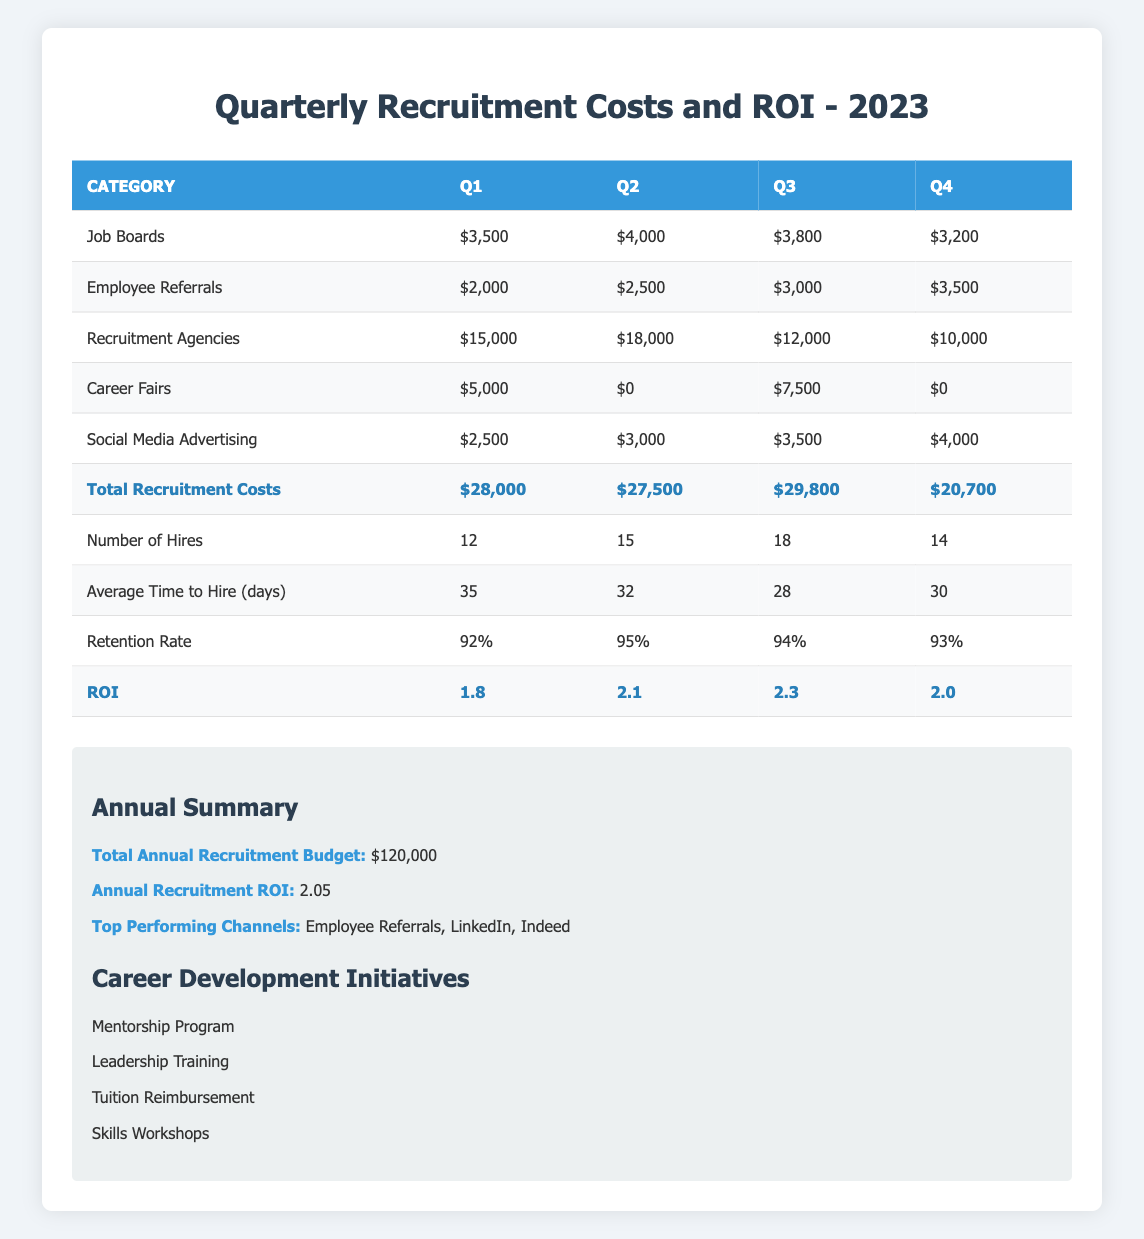What were the total recruitment costs for Q3? The total recruitment costs for Q3 can be found by looking at the row labeled "Total Recruitment Costs" in the Q3 column. The value there is $29,800.
Answer: $29,800 What was the average time to hire in Q2? In the table under the "Average Time to Hire (days)" row for Q2, the value is listed as 32 days.
Answer: 32 days Which quarter had the highest retention rate? To find the highest retention rate, compare the values in the "Retention Rate" row across all quarters. Q2 has the highest value at 95%.
Answer: Q2 What is the total cost for Employee Referrals for the entire year? Sum the costs for Employee Referrals across all four quarters: $2,000 (Q1) + $2,500 (Q2) + $3,000 (Q3) + $3,500 (Q4) = $11,000.
Answer: $11,000 Was the ROI higher for Q3 than for Q1? Q3's ROI is 2.3, and Q1's ROI is 1.8. Since 2.3 is greater than 1.8, the statement is true.
Answer: Yes What is the difference in the number of hires between Q1 and Q4? The number of hires in Q1 is 12 and in Q4 is 14. The difference is 14 - 12 = 2.
Answer: 2 Which quarter had the lowest total recruitment costs, and what was that amount? By comparing the totals in the "Total Recruitment Costs" row, Q4 has the lowest total of $20,700.
Answer: Q4, $20,700 What was the average retention rate for the year? To find the average retention rate, sum the retention rates for all quarters (0.92 + 0.95 + 0.94 + 0.93) and divide by 4. The average is (3.74 / 4) = 0.935, or 93.5%.
Answer: 93.5% How many hires were made in Q3 and Q4 combined? Add the number of hires in Q3 (18) and Q4 (14): 18 + 14 = 32.
Answer: 32 